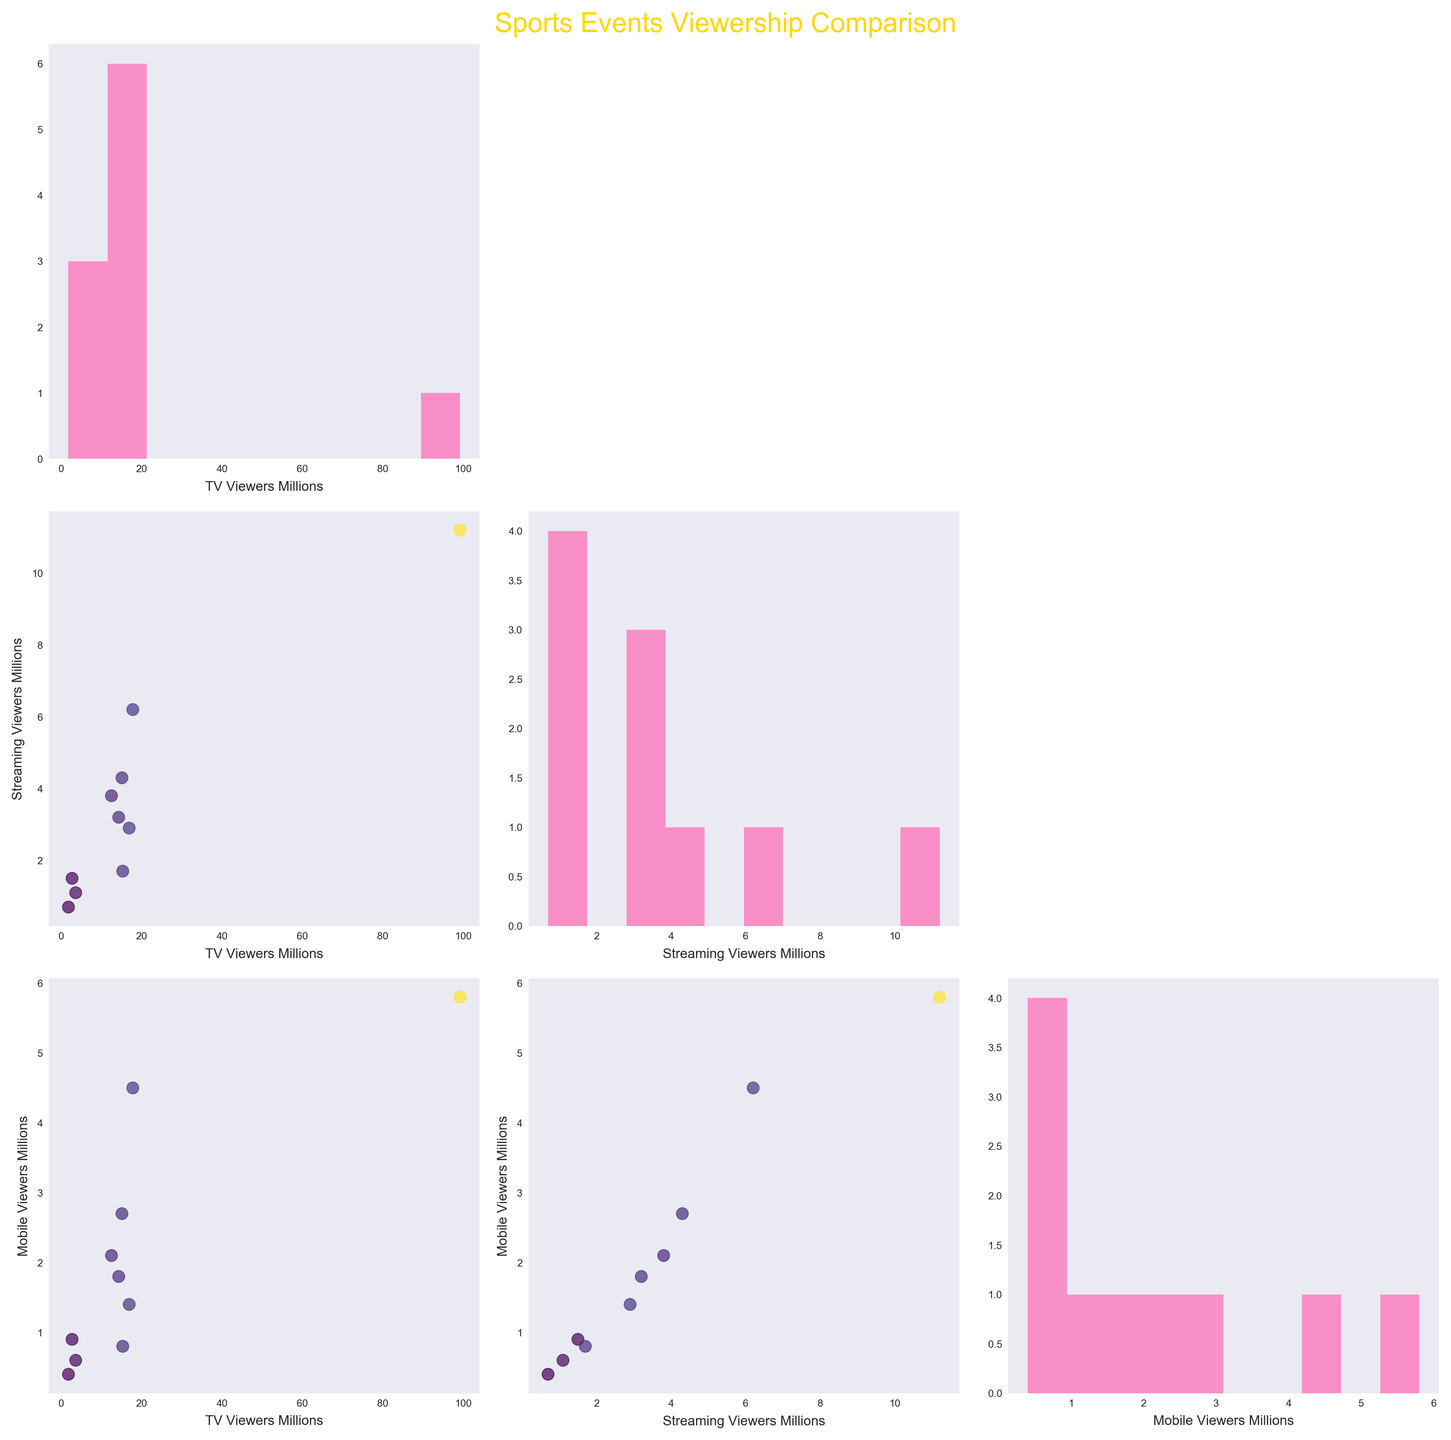What is the title of the figure? The title of the figure is located at the top center and is written in a large font, colored in gold.
Answer: Sports Events Viewership Comparison How many variables are compared in the scatterplot matrix? The figure has a 3x3 grid of plots, indicating three different variables being compared across each pairwise combination and individually.
Answer: 3 What color is used for the histograms? The histograms in the diagonal plots are filled with a single color.
Answer: Pink Which variable is used to color the scatter points? The scatter points in the off-diagonal plots are colored based on the values of one of the variables.
Answer: TV Viewers Millions Are there any missing diagonal elements in the matrix? The missing diagonal elements in the top-right and bottom-left parts of the grid serve a special purpose to avoid redundant data plotting.
Answer: Yes Which event has the highest TV viewership? By looking at the largest number in the histograms or scatter plots, we can identify the event with the highest number of TV viewers.
Answer: Super Bowl LVI What is the relationship between "TV Viewers Millions" and "Mobile Viewers Millions"? By examining the scatter plot in the first row, third column, and how the points align or trend, we can observe their relationship.
Answer: Positive correlation Compare the number of TV viewers to streaming viewers for the World Cup Final. By checking the corresponding points in the scatter plots for TV vs. Streaming or finding their values in each histogram, we can compare the two.
Answer: 17.8 million TV viewers vs. 6.2 million streaming viewers What can you infer about the variance of "Mobile Viewers Millions" based on the histograms? By looking at the spread and shape of the histogram in the third row, third column, we can infer how varied the mobile viewership data is.
Answer: Low variance Between which pair of variables is there the weakest correlation? By observing the scatter plots with scattered or randomly spread points, we can identify which pair of variables has the weakest linear relationship.
Answer: TV Viewers Milllions and Mobile Viewers Millions 